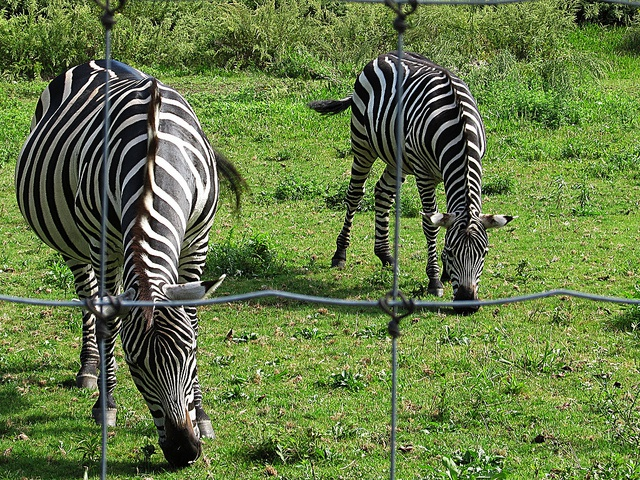Describe the objects in this image and their specific colors. I can see zebra in darkgreen, black, gray, white, and darkgray tones and zebra in darkgreen, black, gray, darkgray, and white tones in this image. 